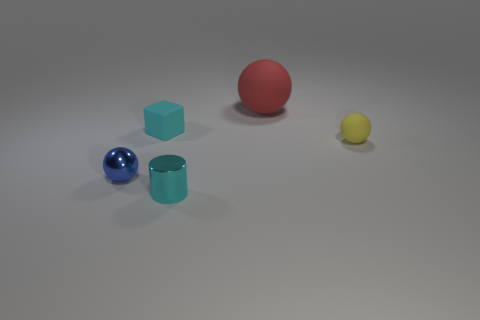Add 5 cylinders. How many objects exist? 10 Subtract all spheres. How many objects are left? 2 Subtract all red spheres. Subtract all tiny yellow things. How many objects are left? 3 Add 1 red matte spheres. How many red matte spheres are left? 2 Add 4 tiny rubber cubes. How many tiny rubber cubes exist? 5 Subtract 0 blue cubes. How many objects are left? 5 